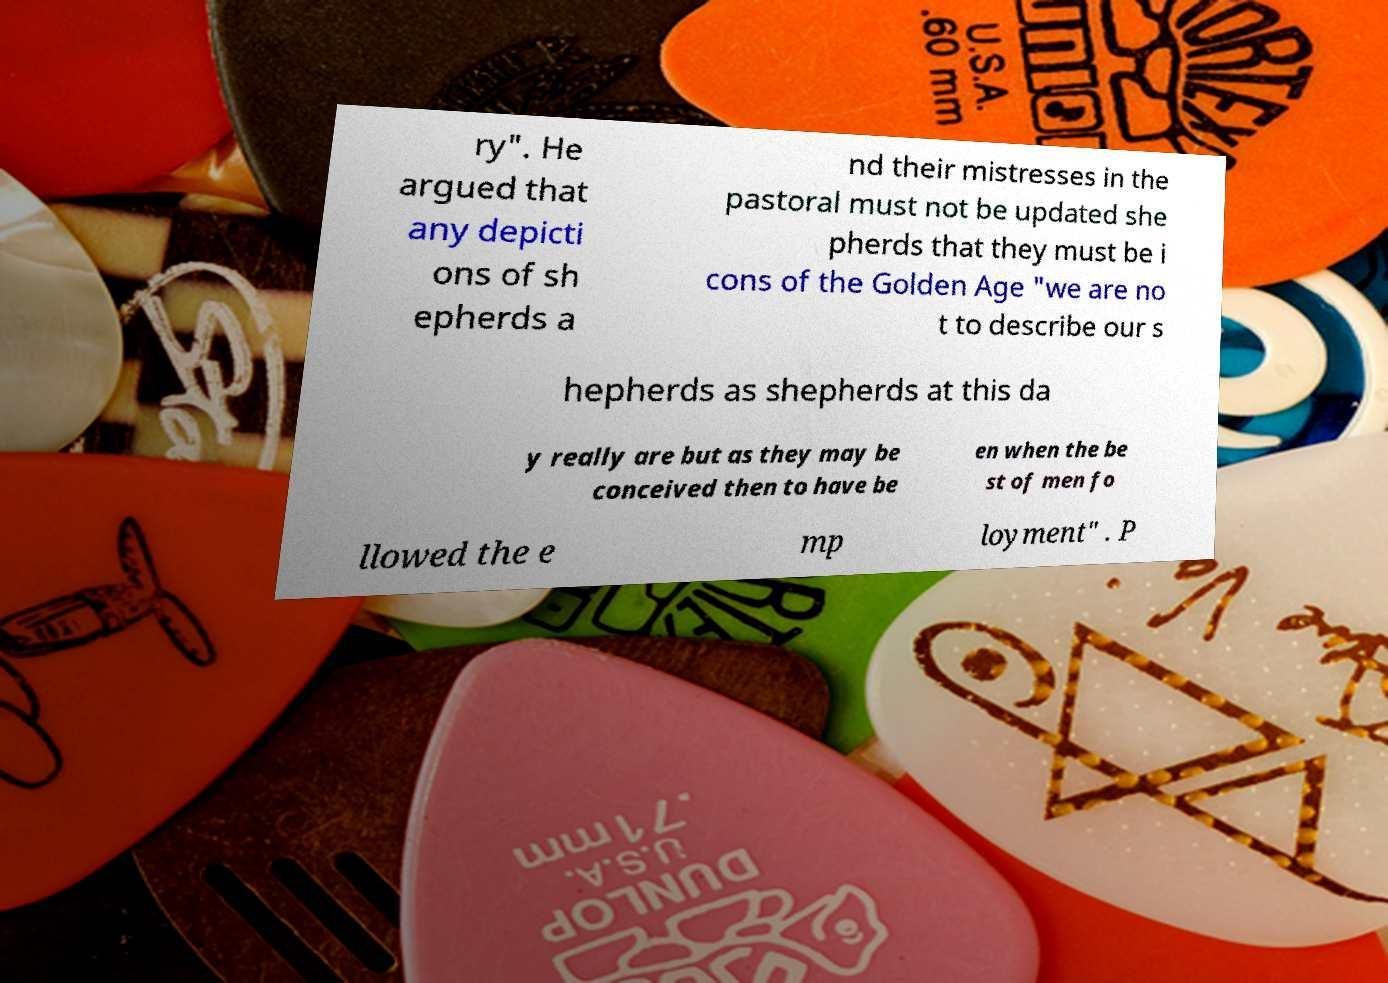Can you accurately transcribe the text from the provided image for me? ry". He argued that any depicti ons of sh epherds a nd their mistresses in the pastoral must not be updated she pherds that they must be i cons of the Golden Age "we are no t to describe our s hepherds as shepherds at this da y really are but as they may be conceived then to have be en when the be st of men fo llowed the e mp loyment" . P 